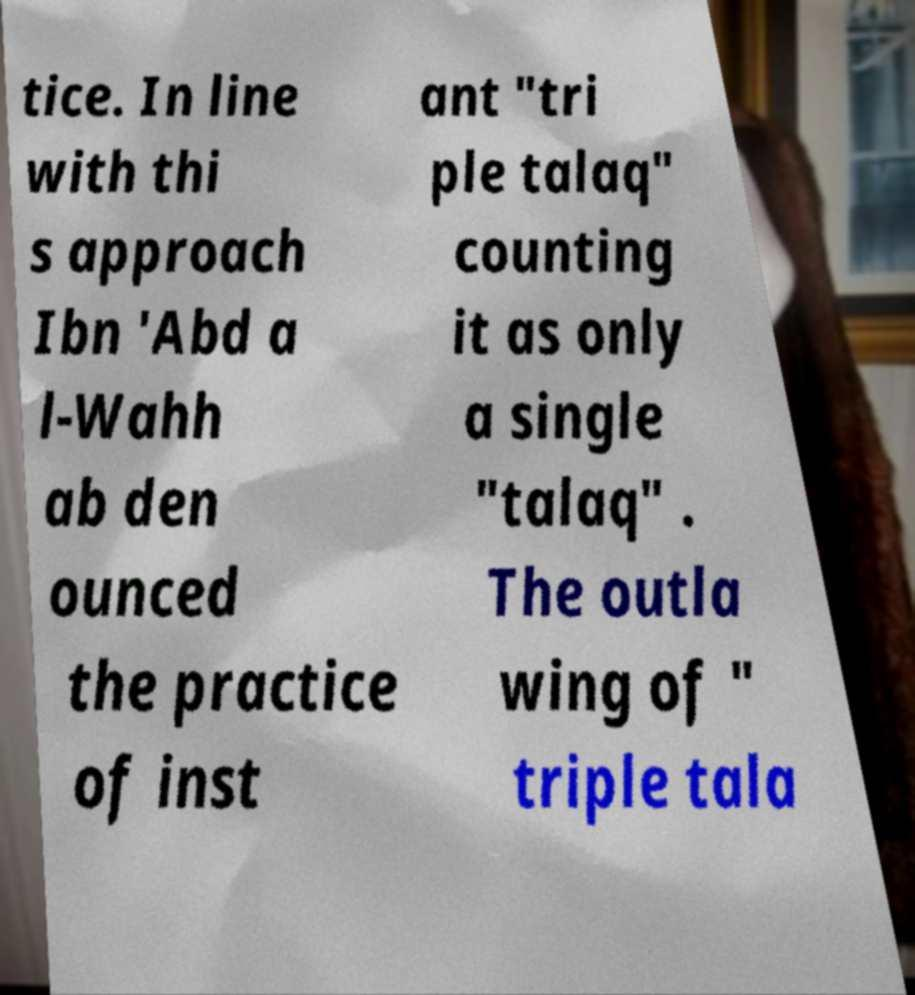What messages or text are displayed in this image? I need them in a readable, typed format. tice. In line with thi s approach Ibn 'Abd a l-Wahh ab den ounced the practice of inst ant "tri ple talaq" counting it as only a single "talaq" . The outla wing of " triple tala 